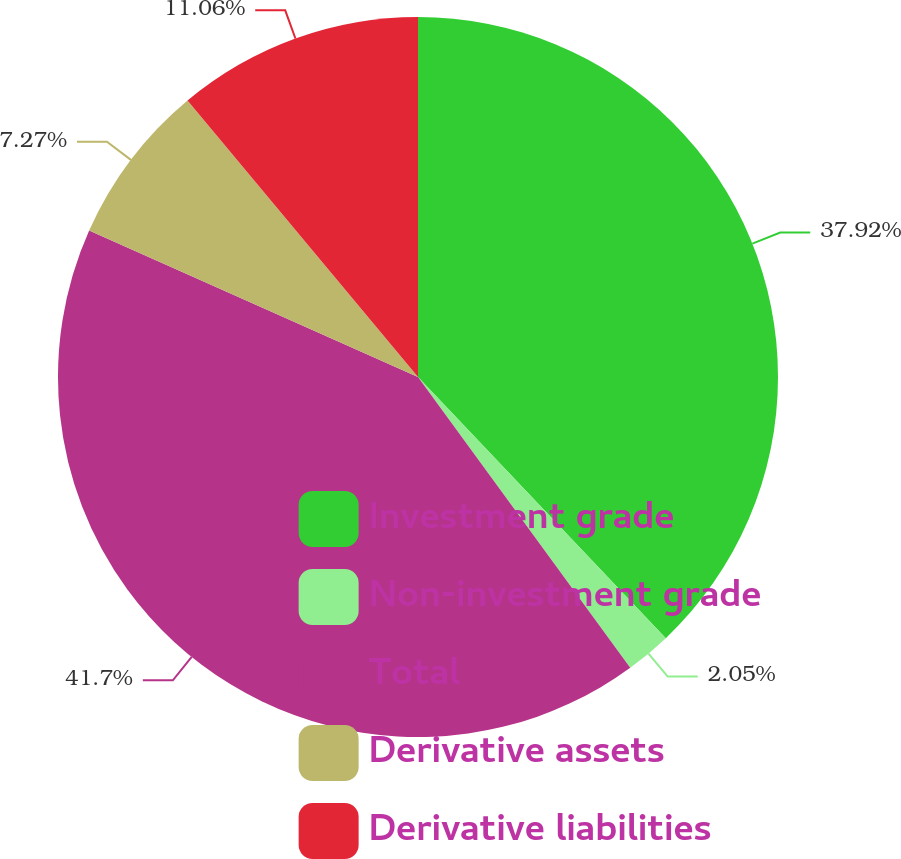Convert chart. <chart><loc_0><loc_0><loc_500><loc_500><pie_chart><fcel>Investment grade<fcel>Non-investment grade<fcel>Total<fcel>Derivative assets<fcel>Derivative liabilities<nl><fcel>37.92%<fcel>2.05%<fcel>41.71%<fcel>7.27%<fcel>11.06%<nl></chart> 